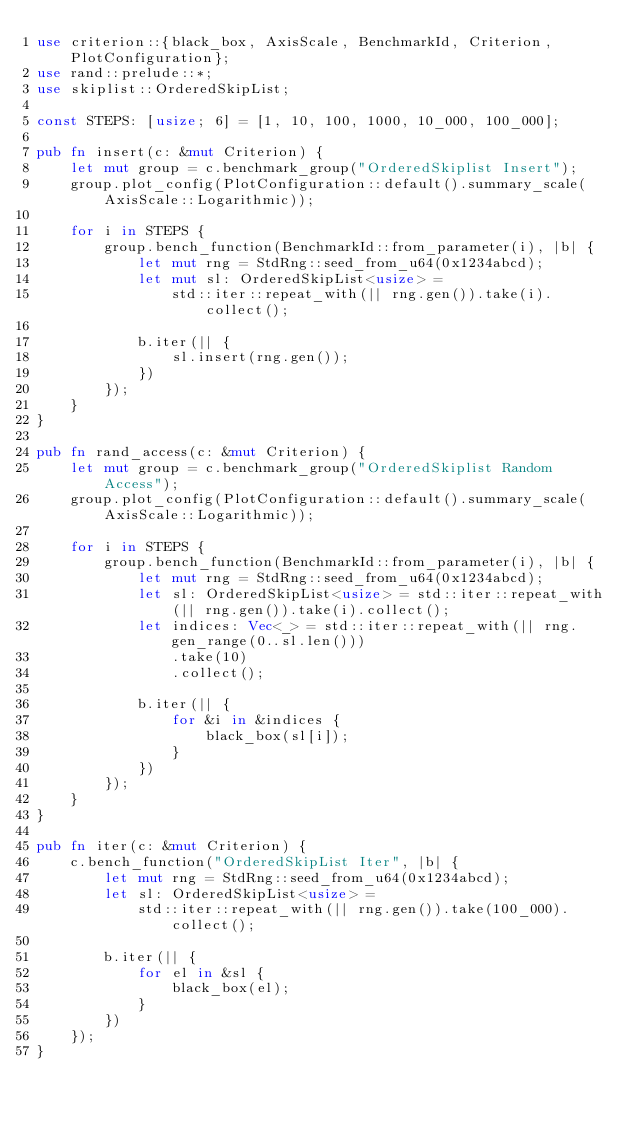Convert code to text. <code><loc_0><loc_0><loc_500><loc_500><_Rust_>use criterion::{black_box, AxisScale, BenchmarkId, Criterion, PlotConfiguration};
use rand::prelude::*;
use skiplist::OrderedSkipList;

const STEPS: [usize; 6] = [1, 10, 100, 1000, 10_000, 100_000];

pub fn insert(c: &mut Criterion) {
    let mut group = c.benchmark_group("OrderedSkiplist Insert");
    group.plot_config(PlotConfiguration::default().summary_scale(AxisScale::Logarithmic));

    for i in STEPS {
        group.bench_function(BenchmarkId::from_parameter(i), |b| {
            let mut rng = StdRng::seed_from_u64(0x1234abcd);
            let mut sl: OrderedSkipList<usize> =
                std::iter::repeat_with(|| rng.gen()).take(i).collect();

            b.iter(|| {
                sl.insert(rng.gen());
            })
        });
    }
}

pub fn rand_access(c: &mut Criterion) {
    let mut group = c.benchmark_group("OrderedSkiplist Random Access");
    group.plot_config(PlotConfiguration::default().summary_scale(AxisScale::Logarithmic));

    for i in STEPS {
        group.bench_function(BenchmarkId::from_parameter(i), |b| {
            let mut rng = StdRng::seed_from_u64(0x1234abcd);
            let sl: OrderedSkipList<usize> = std::iter::repeat_with(|| rng.gen()).take(i).collect();
            let indices: Vec<_> = std::iter::repeat_with(|| rng.gen_range(0..sl.len()))
                .take(10)
                .collect();

            b.iter(|| {
                for &i in &indices {
                    black_box(sl[i]);
                }
            })
        });
    }
}

pub fn iter(c: &mut Criterion) {
    c.bench_function("OrderedSkipList Iter", |b| {
        let mut rng = StdRng::seed_from_u64(0x1234abcd);
        let sl: OrderedSkipList<usize> =
            std::iter::repeat_with(|| rng.gen()).take(100_000).collect();

        b.iter(|| {
            for el in &sl {
                black_box(el);
            }
        })
    });
}
</code> 